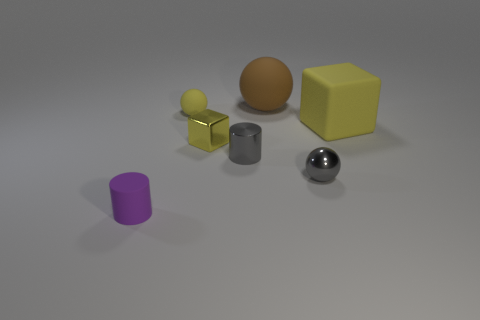Are there any tiny matte things that have the same color as the tiny rubber sphere?
Your response must be concise. No. Is the number of large yellow rubber cubes less than the number of yellow blocks?
Give a very brief answer. Yes. What number of things are small gray metallic spheres or small gray things that are on the right side of the gray cylinder?
Provide a short and direct response. 1. Is there a green thing that has the same material as the tiny gray sphere?
Provide a short and direct response. No. What is the material of the yellow thing that is the same size as the brown rubber object?
Make the answer very short. Rubber. What material is the tiny cylinder that is in front of the tiny cylinder that is behind the tiny purple cylinder made of?
Provide a succinct answer. Rubber. There is a small object that is in front of the tiny metal sphere; is its shape the same as the tiny yellow metal thing?
Keep it short and to the point. No. What is the color of the cylinder that is made of the same material as the brown thing?
Offer a very short reply. Purple. What is the tiny cylinder to the right of the small purple matte object made of?
Keep it short and to the point. Metal. There is a large yellow thing; is it the same shape as the small shiny thing that is in front of the gray cylinder?
Provide a short and direct response. No. 